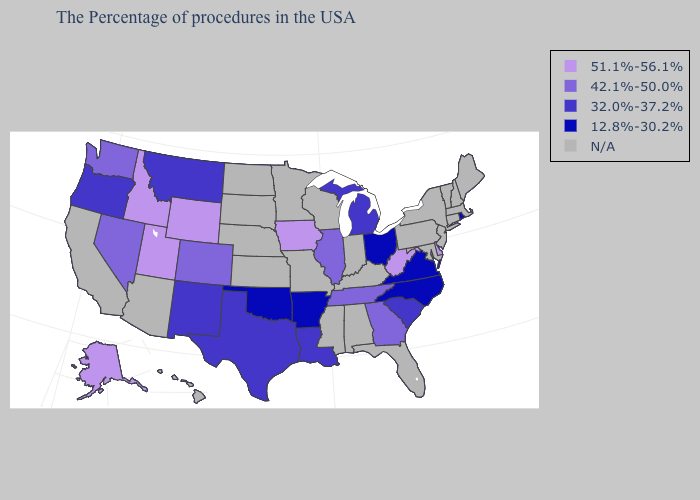Among the states that border Minnesota , which have the highest value?
Concise answer only. Iowa. Does the map have missing data?
Quick response, please. Yes. Which states have the lowest value in the MidWest?
Concise answer only. Ohio. What is the highest value in the USA?
Be succinct. 51.1%-56.1%. Does Delaware have the highest value in the South?
Short answer required. Yes. Does Iowa have the highest value in the MidWest?
Answer briefly. Yes. Is the legend a continuous bar?
Answer briefly. No. Name the states that have a value in the range 42.1%-50.0%?
Be succinct. Georgia, Tennessee, Illinois, Colorado, Nevada, Washington. Name the states that have a value in the range 42.1%-50.0%?
Write a very short answer. Georgia, Tennessee, Illinois, Colorado, Nevada, Washington. Which states have the lowest value in the West?
Write a very short answer. New Mexico, Montana, Oregon. Name the states that have a value in the range 32.0%-37.2%?
Keep it brief. South Carolina, Michigan, Louisiana, Texas, New Mexico, Montana, Oregon. Which states have the lowest value in the MidWest?
Short answer required. Ohio. What is the lowest value in the USA?
Be succinct. 12.8%-30.2%. What is the value of Florida?
Write a very short answer. N/A. 